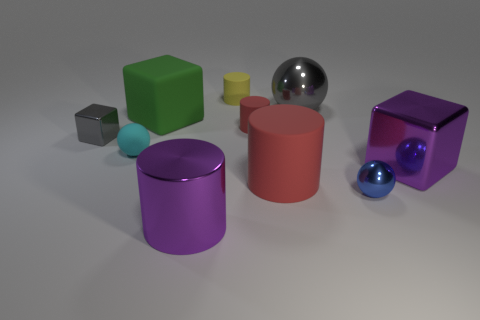Is the color of the large cube that is to the left of the small blue thing the same as the small metallic object that is on the left side of the shiny cylinder?
Keep it short and to the point. No. There is a yellow rubber cylinder; how many rubber cylinders are on the left side of it?
Offer a terse response. 0. What number of blocks are the same color as the big matte cylinder?
Make the answer very short. 0. Are the sphere behind the green object and the purple block made of the same material?
Provide a succinct answer. Yes. What number of tiny red cylinders are made of the same material as the big red cylinder?
Make the answer very short. 1. Is the number of tiny metal blocks that are to the left of the gray metal cube greater than the number of purple shiny things?
Offer a terse response. No. What is the size of the block that is the same color as the large metal sphere?
Offer a very short reply. Small. Is there a big purple rubber thing of the same shape as the tiny yellow thing?
Make the answer very short. No. What number of objects are either big blue rubber things or tiny shiny blocks?
Offer a very short reply. 1. What number of small rubber cylinders are on the right side of the cylinder that is behind the large block that is on the left side of the large metallic sphere?
Your answer should be compact. 1. 